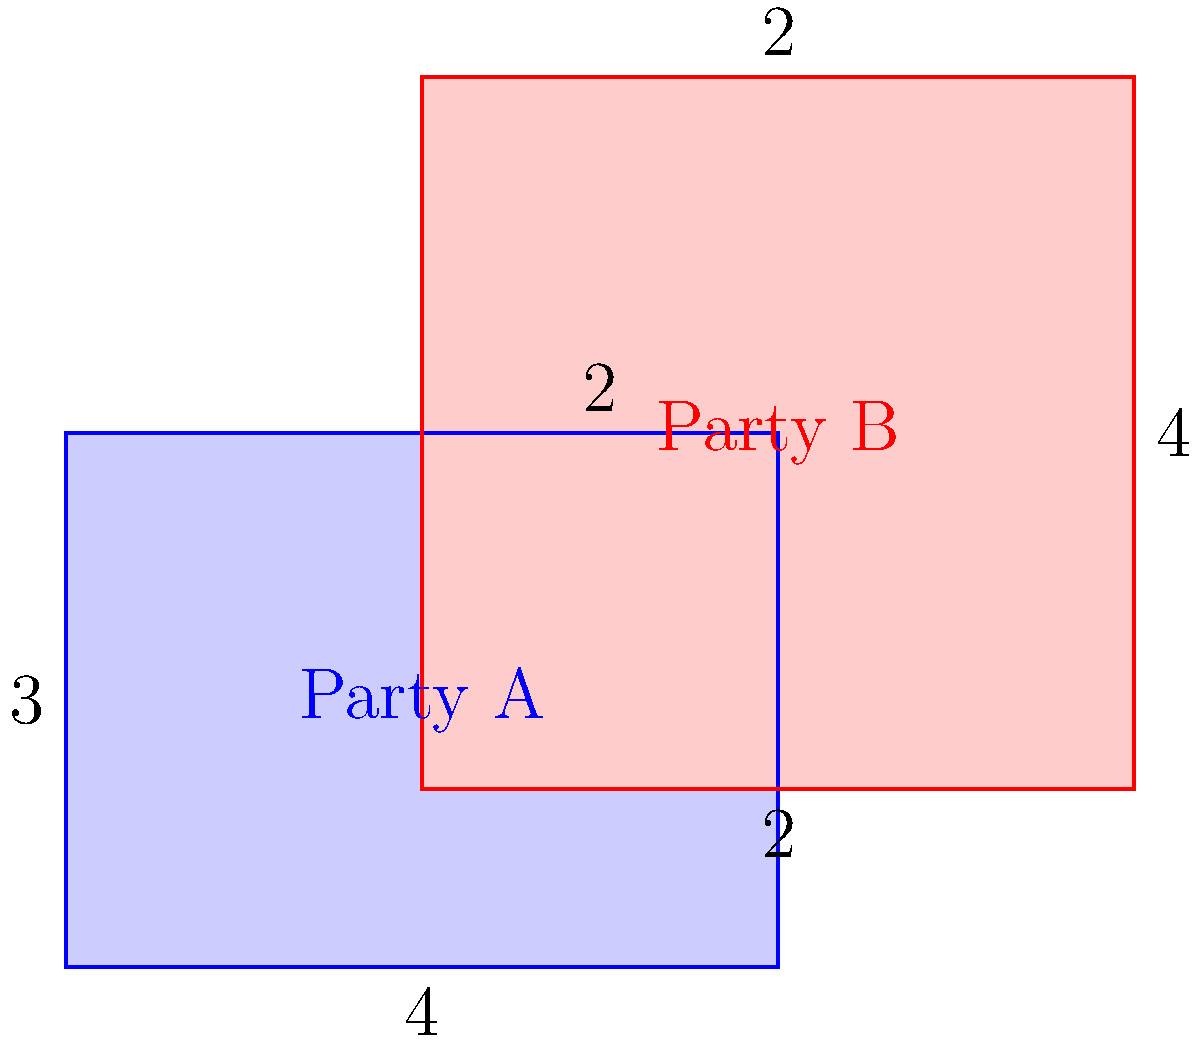In a political landscape analysis, two rectangles represent the influence of Party A and Party B. Party A's influence is represented by a $4 \times 3$ rectangle, while Party B's influence is represented by a $4 \times 4$ rectangle. The rectangles overlap as shown in the diagram. What is the total area of influence for both parties combined? To find the total area of influence for both parties, we need to:

1. Calculate the area of Party A's rectangle:
   $A_A = 4 \times 3 = 12$ square units

2. Calculate the area of Party B's rectangle:
   $A_B = 4 \times 4 = 16$ square units

3. Calculate the area of overlap:
   The overlap is a $2 \times 2$ rectangle
   $A_{overlap} = 2 \times 2 = 4$ square units

4. Calculate the total area by adding the areas of both rectangles and subtracting the overlap:
   $A_{total} = A_A + A_B - A_{overlap}$
   $A_{total} = 12 + 16 - 4 = 24$ square units

Therefore, the total area of influence for both parties combined is 24 square units.
Answer: 24 square units 